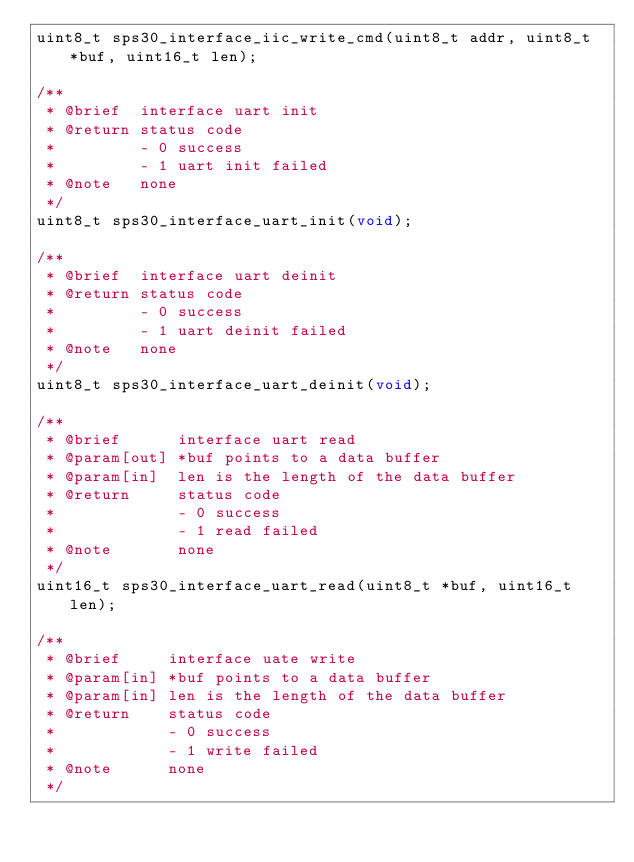Convert code to text. <code><loc_0><loc_0><loc_500><loc_500><_C_>uint8_t sps30_interface_iic_write_cmd(uint8_t addr, uint8_t *buf, uint16_t len);

/**
 * @brief  interface uart init
 * @return status code
 *         - 0 success
 *         - 1 uart init failed
 * @note   none
 */
uint8_t sps30_interface_uart_init(void);

/**
 * @brief  interface uart deinit
 * @return status code
 *         - 0 success
 *         - 1 uart deinit failed
 * @note   none
 */
uint8_t sps30_interface_uart_deinit(void);

/**
 * @brief      interface uart read
 * @param[out] *buf points to a data buffer
 * @param[in]  len is the length of the data buffer
 * @return     status code
 *             - 0 success
 *             - 1 read failed
 * @note       none
 */
uint16_t sps30_interface_uart_read(uint8_t *buf, uint16_t len);

/**
 * @brief     interface uate write
 * @param[in] *buf points to a data buffer
 * @param[in] len is the length of the data buffer
 * @return    status code
 *            - 0 success
 *            - 1 write failed
 * @note      none
 */</code> 